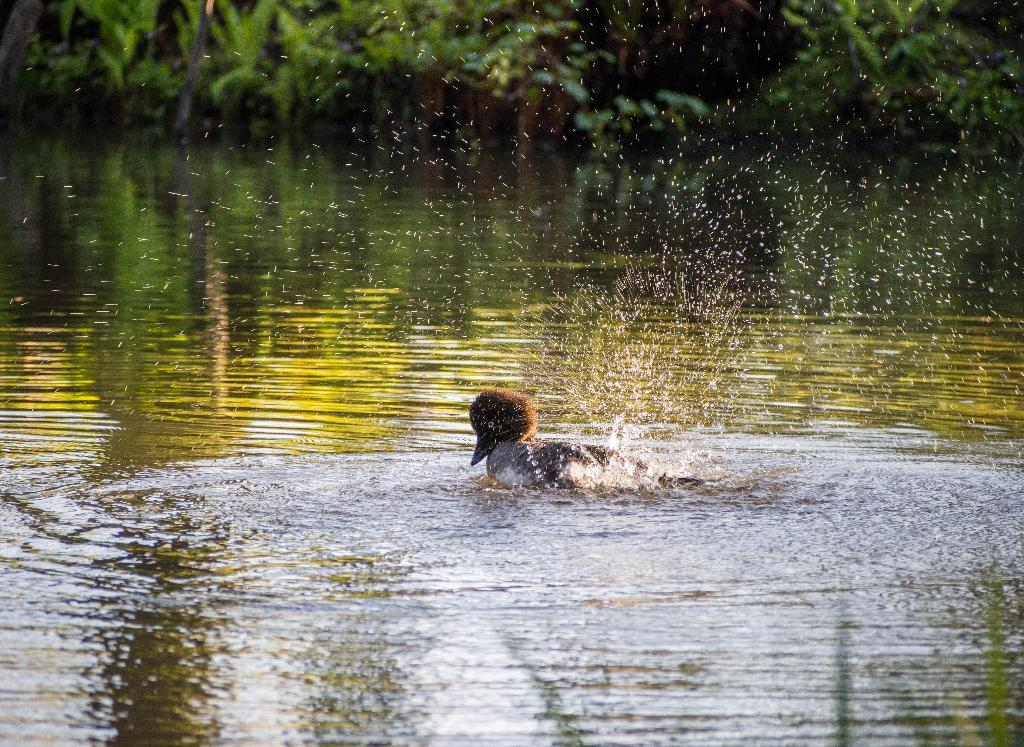What animal is present in the image? There is a duck in the image. What is the duck doing in the image? The duck is swimming in the water. What can be seen at the top of the image? There are plants and leaves visible at the top of the image. What type of hand can be seen holding the duck in the image? There is no hand present in the image; the duck is swimming in the water without any visible interaction with a person or object. 